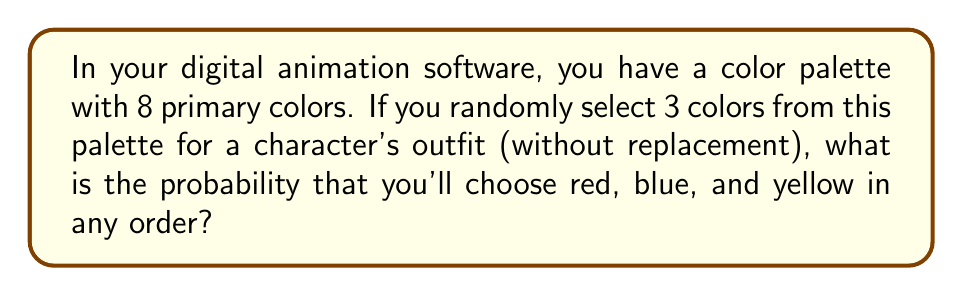Teach me how to tackle this problem. Let's approach this step-by-step:

1) First, we need to calculate the total number of ways to choose 3 colors from 8 colors. This is a combination problem, represented by $\binom{8}{3}$.

   $\binom{8}{3} = \frac{8!}{3!(8-3)!} = \frac{8!}{3!5!} = 56$

2) Now, we need to calculate the number of ways to choose red, blue, and yellow specifically. Since the order doesn't matter, there's only one way to choose these three colors.

3) However, these three colors can be arranged in 3! = 6 different orders.

4) The probability is then:

   $$P(\text{red, blue, yellow}) = \frac{\text{favorable outcomes}}{\text{total outcomes}} = \frac{6}{\binom{8}{3}} = \frac{6}{56}$$

5) Simplifying this fraction:

   $$\frac{6}{56} = \frac{3}{28} \approx 0.1071$$
Answer: $\frac{3}{28}$ 